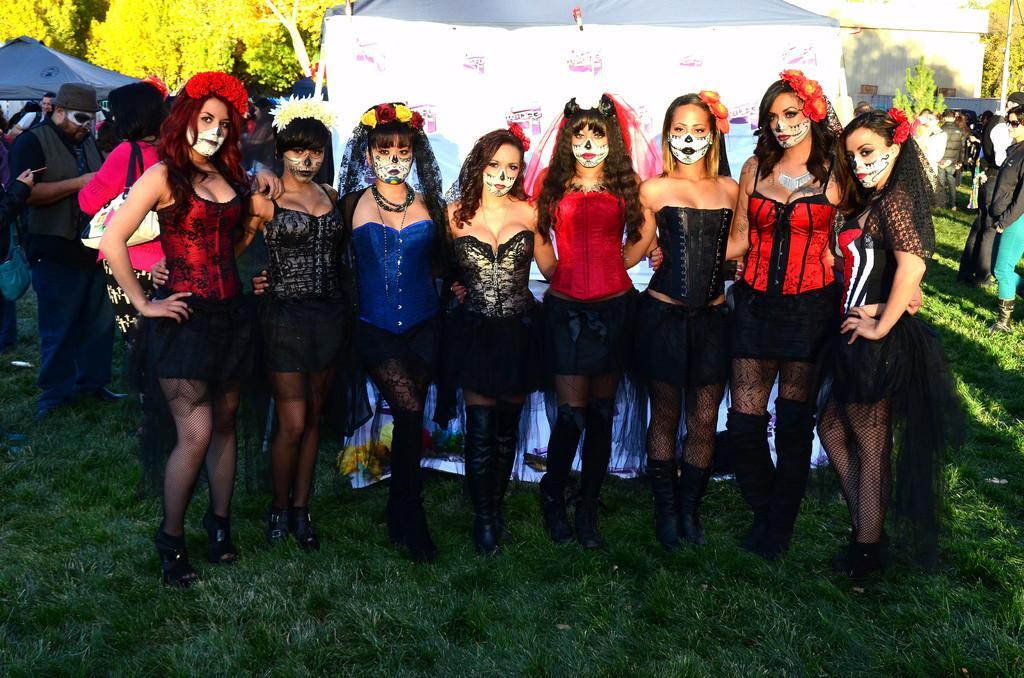Could you give a brief overview of what you see in this image? In the center of the image we can see women standing on the grass. In the background we can see tents, house, trees and persons. 